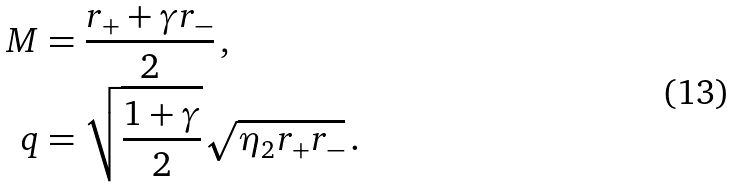<formula> <loc_0><loc_0><loc_500><loc_500>M & = \frac { r _ { + } + \gamma r _ { - } } { 2 } \, , \\ q & = \sqrt { \frac { 1 + \gamma } { 2 } } \sqrt { \eta _ { 2 } r _ { + } r _ { - } } \, .</formula> 